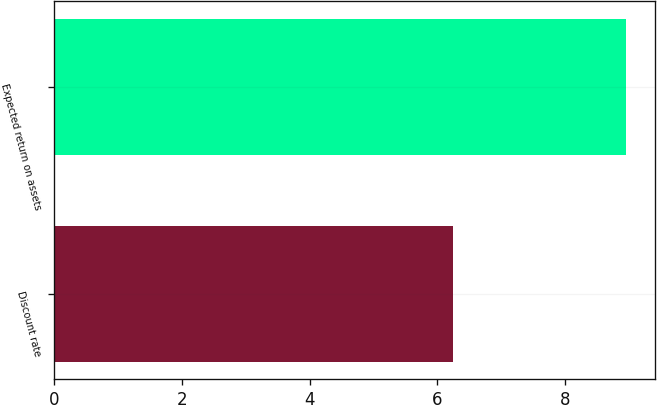Convert chart to OTSL. <chart><loc_0><loc_0><loc_500><loc_500><bar_chart><fcel>Discount rate<fcel>Expected return on assets<nl><fcel>6.25<fcel>8.96<nl></chart> 